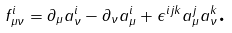<formula> <loc_0><loc_0><loc_500><loc_500>f ^ { i } _ { \mu \nu } = \partial _ { \mu } a ^ { i } _ { \nu } - \partial _ { \nu } a ^ { i } _ { \mu } + \epsilon ^ { i j k } a ^ { j } _ { \mu } a ^ { k } _ { \nu } \text {.}</formula> 